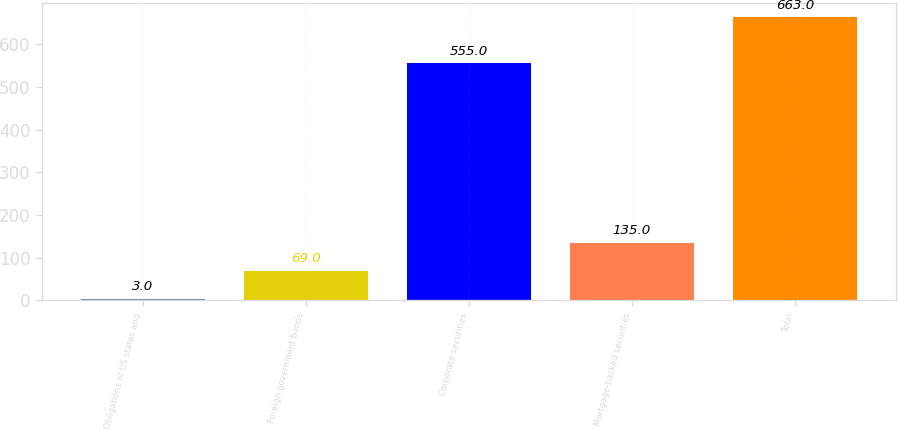<chart> <loc_0><loc_0><loc_500><loc_500><bar_chart><fcel>Obligations of US states and<fcel>Foreign government bonds<fcel>Corporate securities<fcel>Mortgage-backed securities<fcel>Total<nl><fcel>3<fcel>69<fcel>555<fcel>135<fcel>663<nl></chart> 